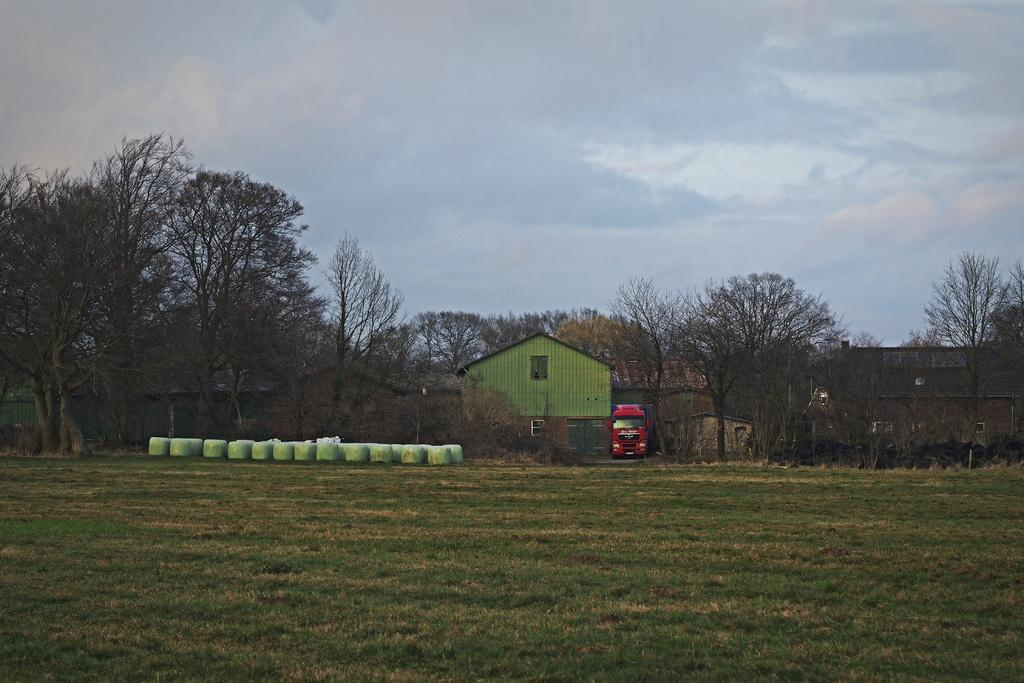What type of natural environment is visible in the image? Grass is visible in the image, indicating a natural environment. What type of man-made structure can be seen in the image? There is a vehicle and sheds in the image, which are man-made structures. What other natural elements are present in the image? Trees are present in the image, in addition to the grass. What is the background of the image? The sky is visible in the background of the image, with clouds present. Can you describe the wall in the image? Yes, there is a wall in the image. How many objects are visible in the image? There are some objects in the image, but the exact number is not specified. What song is being sung by the crowd of sisters in the image? There is no song, crowd, or sisters present in the image. 